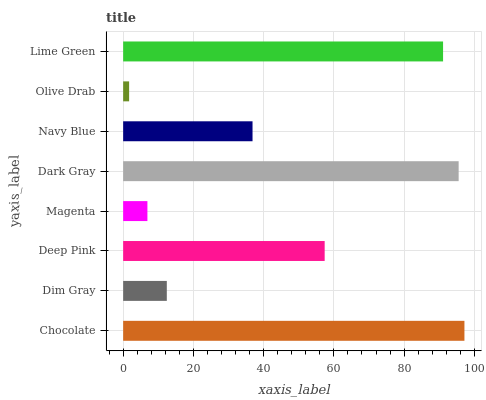Is Olive Drab the minimum?
Answer yes or no. Yes. Is Chocolate the maximum?
Answer yes or no. Yes. Is Dim Gray the minimum?
Answer yes or no. No. Is Dim Gray the maximum?
Answer yes or no. No. Is Chocolate greater than Dim Gray?
Answer yes or no. Yes. Is Dim Gray less than Chocolate?
Answer yes or no. Yes. Is Dim Gray greater than Chocolate?
Answer yes or no. No. Is Chocolate less than Dim Gray?
Answer yes or no. No. Is Deep Pink the high median?
Answer yes or no. Yes. Is Navy Blue the low median?
Answer yes or no. Yes. Is Navy Blue the high median?
Answer yes or no. No. Is Olive Drab the low median?
Answer yes or no. No. 